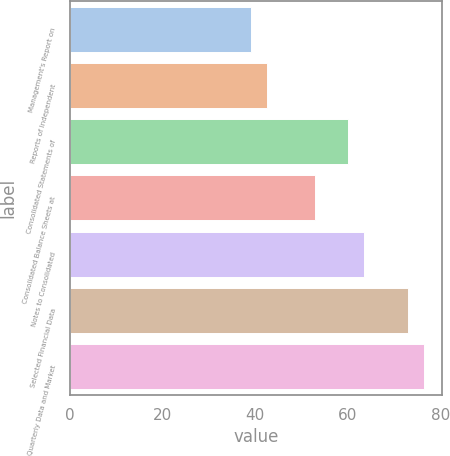<chart> <loc_0><loc_0><loc_500><loc_500><bar_chart><fcel>Management's Report on<fcel>Reports of Independent<fcel>Consolidated Statements of<fcel>Consolidated Balance Sheets at<fcel>Notes to Consolidated<fcel>Selected Financial Data<fcel>Quarterly Data and Market<nl><fcel>39<fcel>42.5<fcel>60<fcel>53<fcel>63.5<fcel>73<fcel>76.5<nl></chart> 